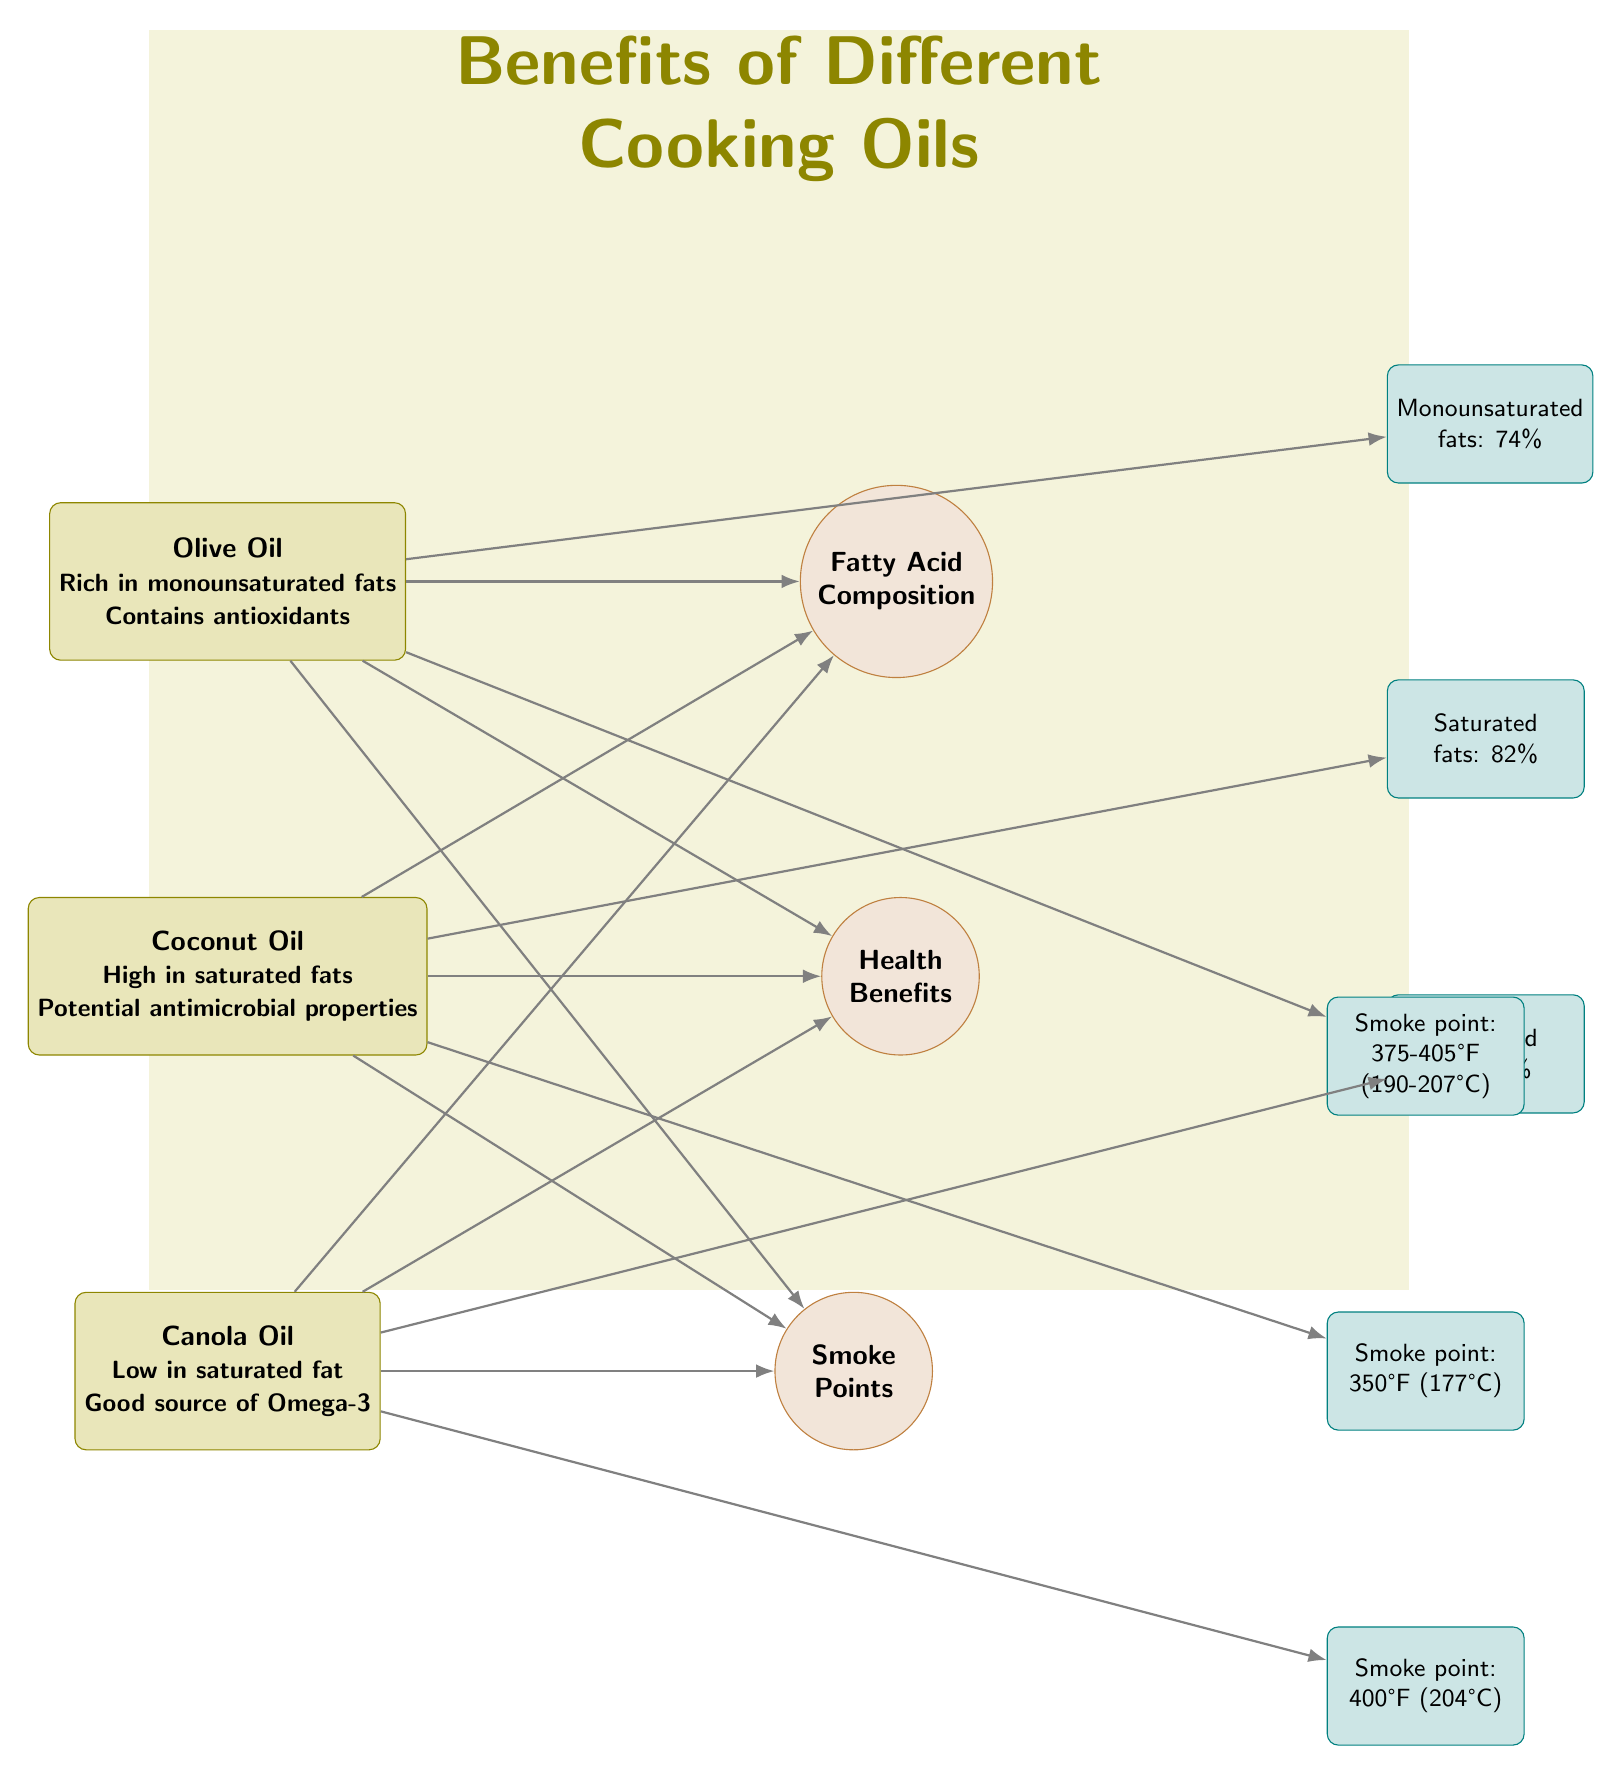What cooking oil has the highest percentage of saturated fats? The diagram lists coconut oil with 82% saturated fats. By examining the fatty acid composition of each oil and comparing their saturated fats, it's clear that coconut oil holds the highest percentage.
Answer: 82% What is the smoke point of canola oil? The diagram shows that canola oil has a smoke point of 400°F (204°C). The smoke point details for each oil are explicitly mentioned in the corresponding section for canola oil.
Answer: 400°F (204°C) How many cooking oils are compared in the diagram? The diagram features three cooking oils: olive oil, coconut oil, and canola oil. By counting the main oil nodes presented, it is apparent that there are three distinct oils.
Answer: 3 Which oil is a good source of Omega-3? The diagram indicates that canola oil is a good source of Omega-3. This detail is associated with the health benefits section for canola oil specifically.
Answer: Canola Oil Which oil is rich in monounsaturated fats? The diagram states that olive oil is rich in monounsaturated fats. The health benefits description for olive oil emphasizes its richness in this type of fat.
Answer: Olive Oil Which cooking oil has the lowest percentage of saturated fats? According to the diagram, canola oil has the lowest percentage of saturated fats at 7%. Comparing the fatty acid compositions, canola oil is identified as having the least saturation.
Answer: 7% What health benefit is associated with coconut oil? The diagram notes that coconut oil has potential antimicrobial properties. This health benefit is specifically linked to coconut oil under the health benefits section.
Answer: Antimicrobial properties What’s the fatty acid composition of olive oil? The diagram reveals that olive oil contains 74% monounsaturated fats. This detail is specifically highlighted in the fatty acid composition associated with olive oil.
Answer: 74% What is the smoke point of olive oil? The diagram indicates that olive oil has a smoke point range of 375-405°F (190-207°C). This information can be found in the smoke points section for olive oil.
Answer: 375-405°F (190-207°C) 